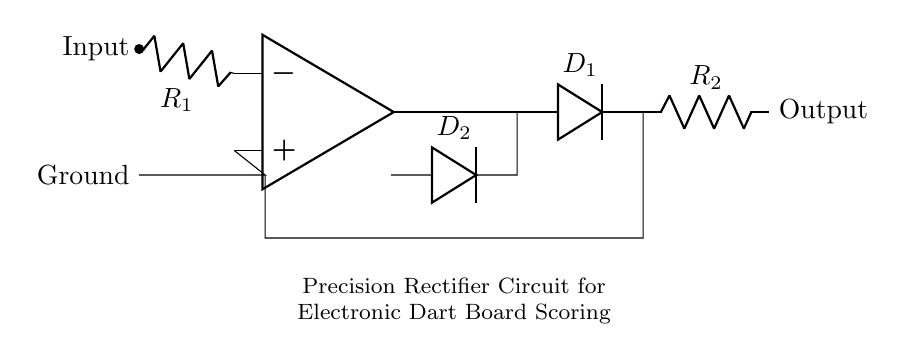What type of op-amp configuration is shown in this circuit? The circuit diagram showcases an inverting amplifier configuration of an operational amplifier (op-amp), evidenced by the negative feedback and input from the inverting terminal.
Answer: inverting amplifier What is the function of the diode D1 in this circuit? Diode D1 serves the purpose of allowing current to flow only in one direction during the positive cycle, thereby enabling rectification for the scoring system.
Answer: rectification How many resistors are present in this precision rectifier circuit? The diagram displays two resistors, labeled R1 and R2, which contribute to setting the gain and output characteristics of the op-amp.
Answer: two What happens to the output signal when the input voltage is negative? When the input voltage is negative, diode D2 conducts and effectively clamps the output to ground, preventing negative output voltage and ensuring accurate scoring.
Answer: clamped to ground What is the output type of this precision rectifier? The output is a positive voltage, as the precision rectifier is designed to remove negative portions of the input signal for accurate scoring in the dart board.
Answer: positive voltage What is the purpose of the second diode D2 in this circuit? Diode D2 is used to ensure that the output remains at zero volts or ground when the input signal is negative, preventing errors in scoring from negative readings.
Answer: prevent negative output What is the primary application of this precision rectifier circuit? This precision rectifier circuit is primarily used in electronic dart boards to achieve accurate scoring by precisely processing the signals generated during gameplay.
Answer: electronic dart boards 